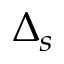Convert formula to latex. <formula><loc_0><loc_0><loc_500><loc_500>\Delta _ { s }</formula> 